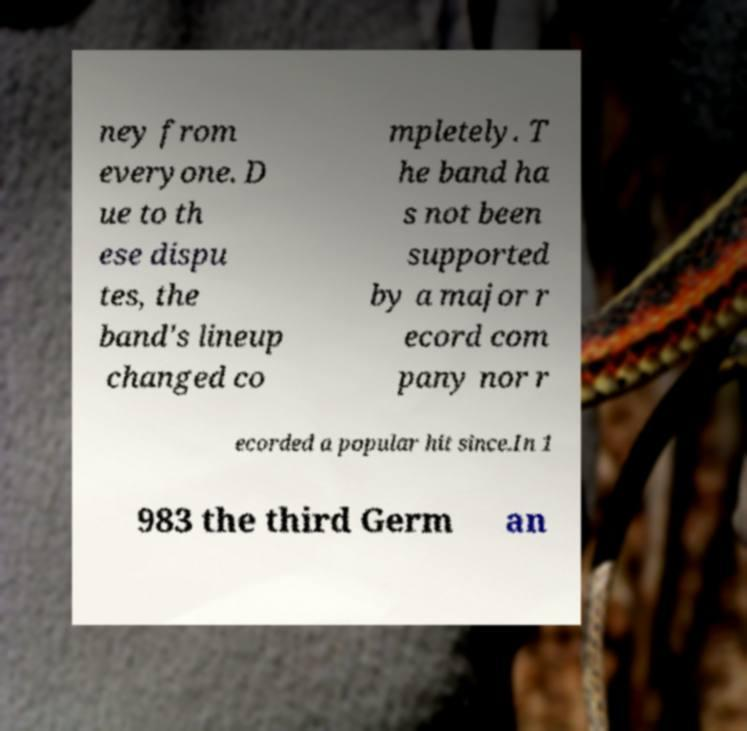Please read and relay the text visible in this image. What does it say? ney from everyone. D ue to th ese dispu tes, the band's lineup changed co mpletely. T he band ha s not been supported by a major r ecord com pany nor r ecorded a popular hit since.In 1 983 the third Germ an 